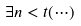Convert formula to latex. <formula><loc_0><loc_0><loc_500><loc_500>\exists n < t ( \cdots )</formula> 